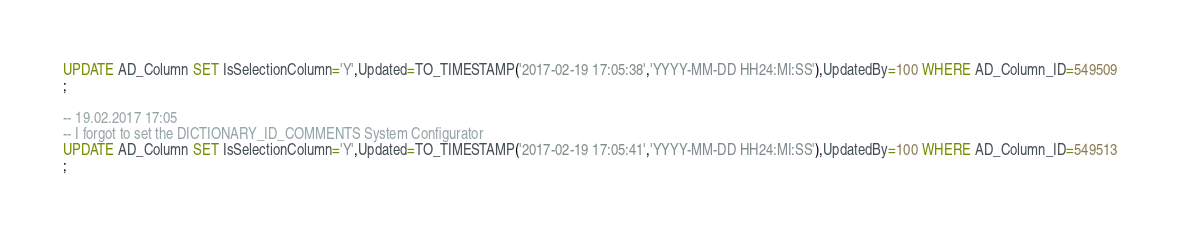Convert code to text. <code><loc_0><loc_0><loc_500><loc_500><_SQL_>UPDATE AD_Column SET IsSelectionColumn='Y',Updated=TO_TIMESTAMP('2017-02-19 17:05:38','YYYY-MM-DD HH24:MI:SS'),UpdatedBy=100 WHERE AD_Column_ID=549509
;

-- 19.02.2017 17:05
-- I forgot to set the DICTIONARY_ID_COMMENTS System Configurator
UPDATE AD_Column SET IsSelectionColumn='Y',Updated=TO_TIMESTAMP('2017-02-19 17:05:41','YYYY-MM-DD HH24:MI:SS'),UpdatedBy=100 WHERE AD_Column_ID=549513
;

</code> 